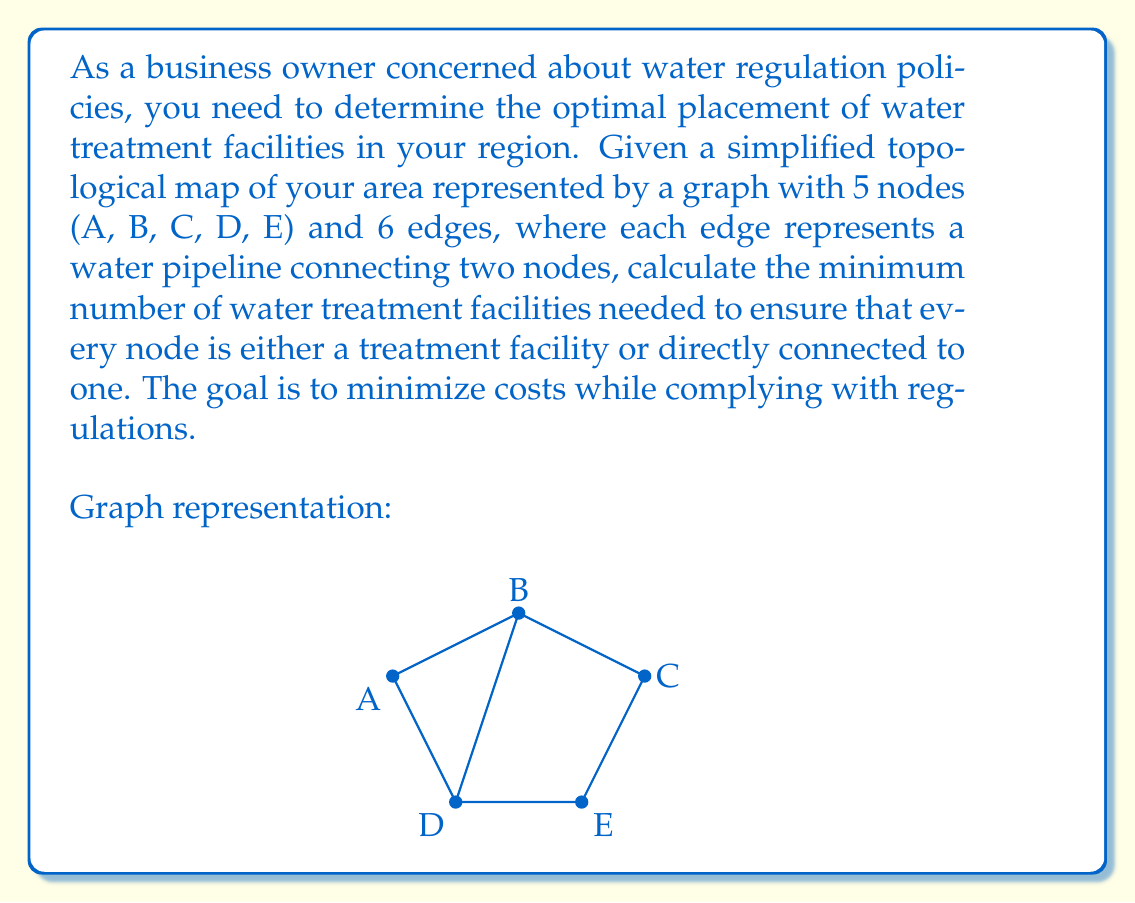Could you help me with this problem? To solve this problem, we need to find the minimum dominating set of the graph, which represents the optimal placement of water treatment facilities. A dominating set is a subset of nodes such that every node in the graph is either in the set or adjacent to a node in the set.

Let's approach this step-by-step:

1) First, we analyze the degree (number of connections) of each node:
   A: degree 2
   B: degree 3
   C: degree 2
   D: degree 3
   E: degree 2

2) Nodes with higher degrees are good candidates for placement as they cover more adjacent nodes.

3) We start with node B, which has the highest degree. Placing a facility at B covers nodes A, B, and D.

4) After covering B, A, and D, we need to cover C and E. We can do this by placing a facility at either C or E.

5) Let's choose C. Now all nodes are either a facility (B and C) or directly connected to one (A, D, and E).

6) We have covered all nodes with just two facilities, located at B and C.

7) To prove this is minimal, we can observe that no single node can cover all others, so we need at least two facilities.

Therefore, the minimum number of water treatment facilities needed is 2.

This solution minimizes costs by using the fewest number of facilities while ensuring compliance with water treatment regulations for all nodes in the network.
Answer: The minimum number of water treatment facilities needed is 2, optimally placed at nodes B and C. 